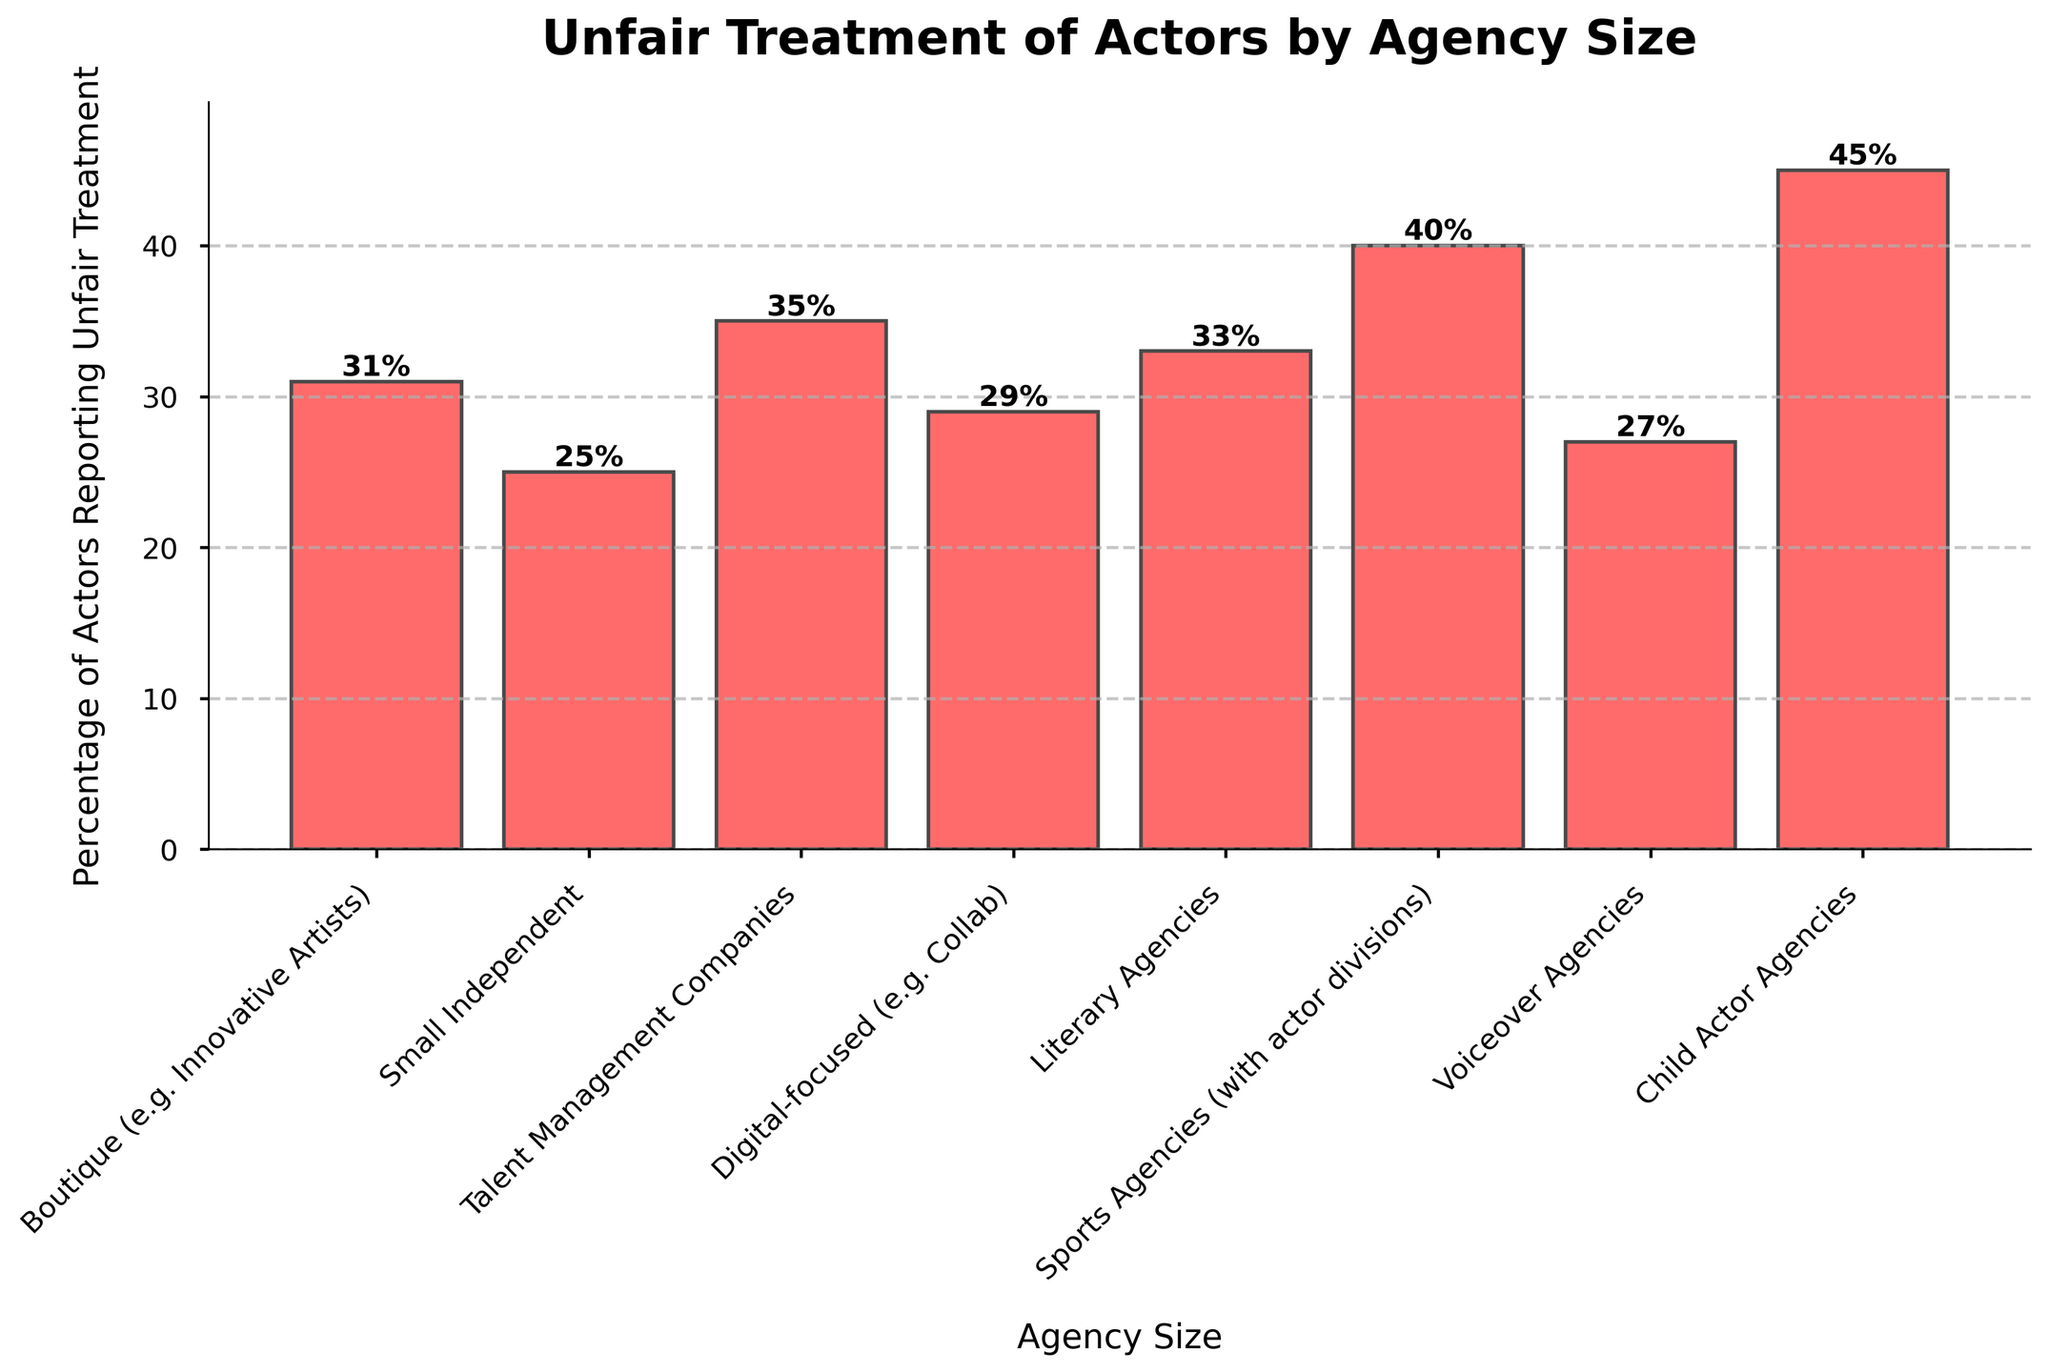What percentage of actors represented by Child Actor Agencies report unfair treatment? Identify the bar labeled 'Child Actor Agencies' and read its height. It shows 45%.
Answer: 45% Which agency size has the lowest percentage of actors reporting unfair treatment? Compare the heights of all the bars and identify the shortest one, which corresponds to Small Independent agencies. The percentage is 25%.
Answer: Small Independent How much higher is the reported unfair treatment percentage for Sports Agencies compared to Digital-focused agencies? Subtract the percentage for Digital-focused (29%) from the percentage for Sports Agencies (40%). The difference is 11%.
Answer: 11% What's the average percentage of actors reporting unfair treatment across all agency sizes? Add all the percentages (31 + 25 + 35 + 29 + 33 + 40 + 27 + 45) to get 265. There are 8 categories, so the average is 265/8 = 33.125%.
Answer: 33.125% Are there more actors reporting unfair treatment in Sports Agencies or in Literary Agencies? Compare the percentages for Sports Agencies (40%) and Literary Agencies (33%). The percentage is higher for Sports Agencies.
Answer: Sports Agencies Which agency size has a percentage of actors reporting unfair treatment closest to the overall average? The overall average is 33.125%. Compare this to each agency's percentage and find that Literary Agencies' 33% is the closest.
Answer: Literary Agencies Are the percentages for Boutique agencies and Talent Management Companies higher or lower than 30%? Compare both values against 30%. Boutique agencies (31%) and Talent Management Companies (35%) are both higher than 30%.
Answer: Higher What is the difference in reported unfair treatment between the highest and lowest agency sizes? Identify the highest percentage (Child Actor Agencies - 45%) and the lowest (Small Independent - 25%), then subtract the lowest from the highest: 45% - 25% = 20%.
Answer: 20% Which agency categories fall below the 30% threshold for reported unfair treatment? Identify any bars below 30%. These are Small Independent (25%) and Voiceover Agencies (27%).
Answer: Small Independent, Voiceover Agencies 